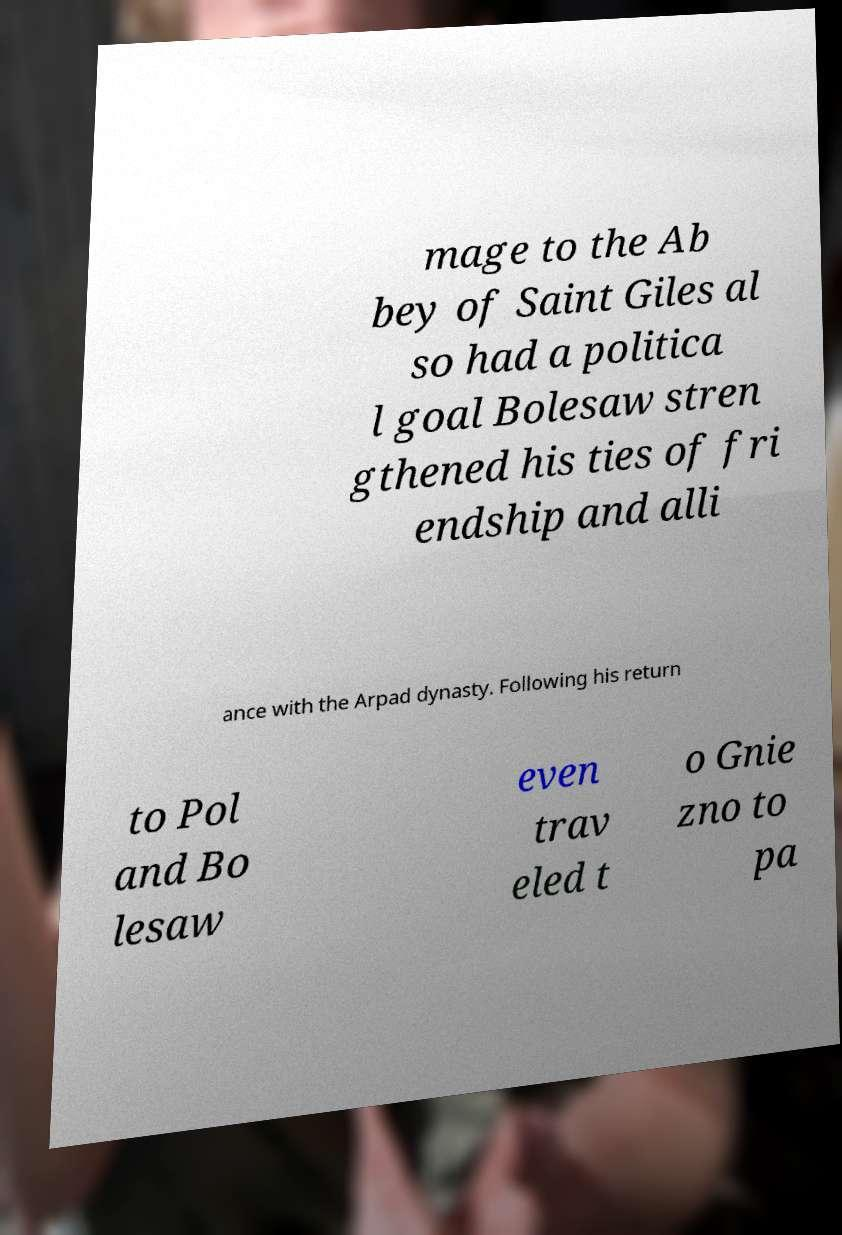Can you accurately transcribe the text from the provided image for me? mage to the Ab bey of Saint Giles al so had a politica l goal Bolesaw stren gthened his ties of fri endship and alli ance with the Arpad dynasty. Following his return to Pol and Bo lesaw even trav eled t o Gnie zno to pa 